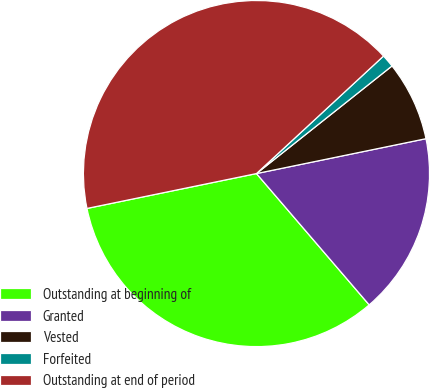<chart> <loc_0><loc_0><loc_500><loc_500><pie_chart><fcel>Outstanding at beginning of<fcel>Granted<fcel>Vested<fcel>Forfeited<fcel>Outstanding at end of period<nl><fcel>33.06%<fcel>16.94%<fcel>7.45%<fcel>1.2%<fcel>41.35%<nl></chart> 